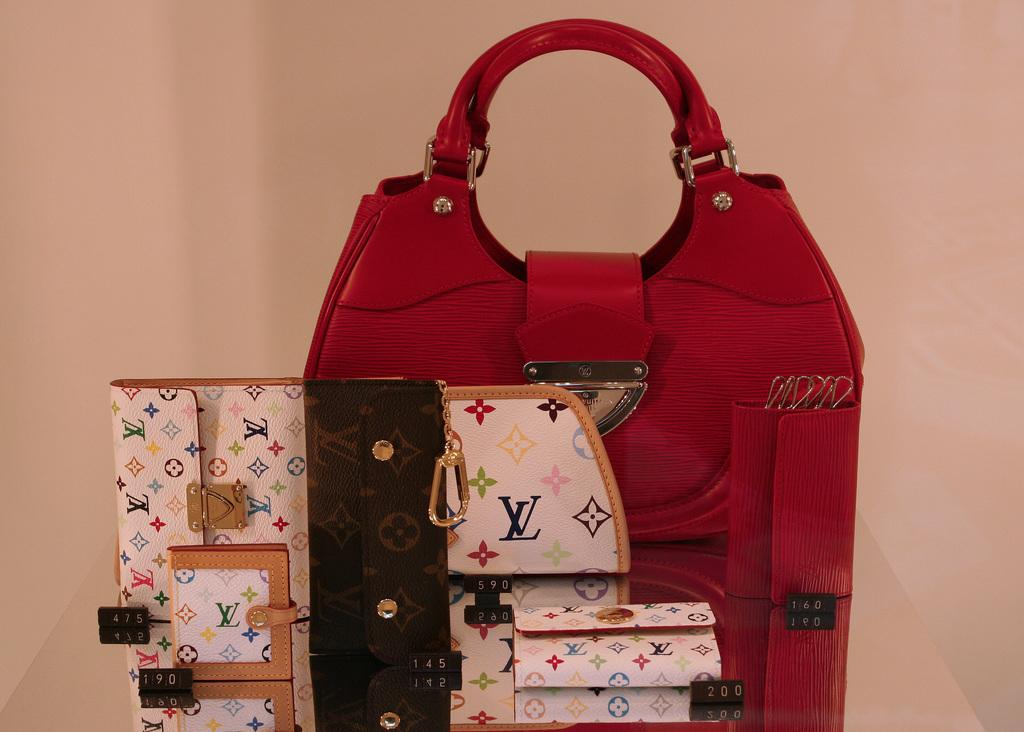What type of bag can be seen in the image with a red color? There is a red color bag in the image. What other type of bag is present in the image? There is a box-type bag with chains in the image. What arithmetic problem can be solved using the bags in the image? There is no arithmetic problem present in the image, as it only features two bags. What type of stove is visible in the image? There is no stove present in the image; it only features two bags. 